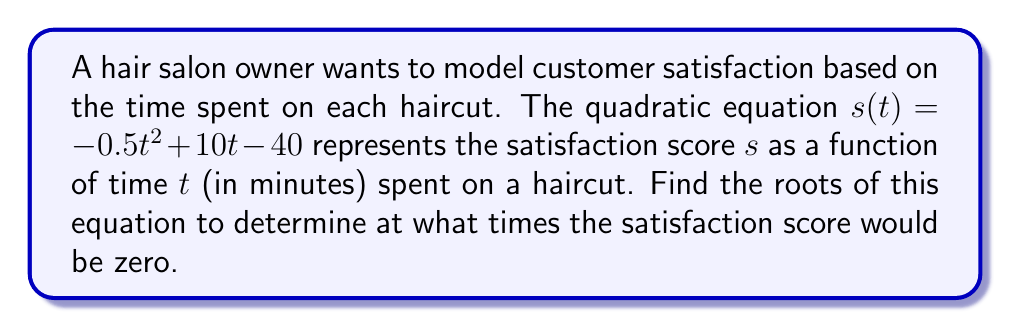What is the answer to this math problem? 1) We start with the quadratic equation:
   $s(t) = -0.5t^2 + 10t - 40$

2) To find the roots, we set $s(t) = 0$:
   $0 = -0.5t^2 + 10t - 40$

3) This is in the standard form $at^2 + bt + c = 0$, where:
   $a = -0.5$, $b = 10$, and $c = -40$

4) We can use the quadratic formula: $t = \frac{-b \pm \sqrt{b^2 - 4ac}}{2a}$

5) Substituting our values:
   $t = \frac{-10 \pm \sqrt{10^2 - 4(-0.5)(-40)}}{2(-0.5)}$

6) Simplifying under the square root:
   $t = \frac{-10 \pm \sqrt{100 - 80}}{-1} = \frac{-10 \pm \sqrt{20}}{-1}$

7) Simplifying further:
   $t = \frac{-10 \pm 2\sqrt{5}}{-1}$

8) This gives us two solutions:
   $t_1 = \frac{-10 + 2\sqrt{5}}{-1} = 10 - 2\sqrt{5}$
   $t_2 = \frac{-10 - 2\sqrt{5}}{-1} = 10 + 2\sqrt{5}$

Therefore, the satisfaction score would be zero at approximately 5.53 minutes and 14.47 minutes.
Answer: $t_1 = 10 - 2\sqrt{5}$, $t_2 = 10 + 2\sqrt{5}$ 